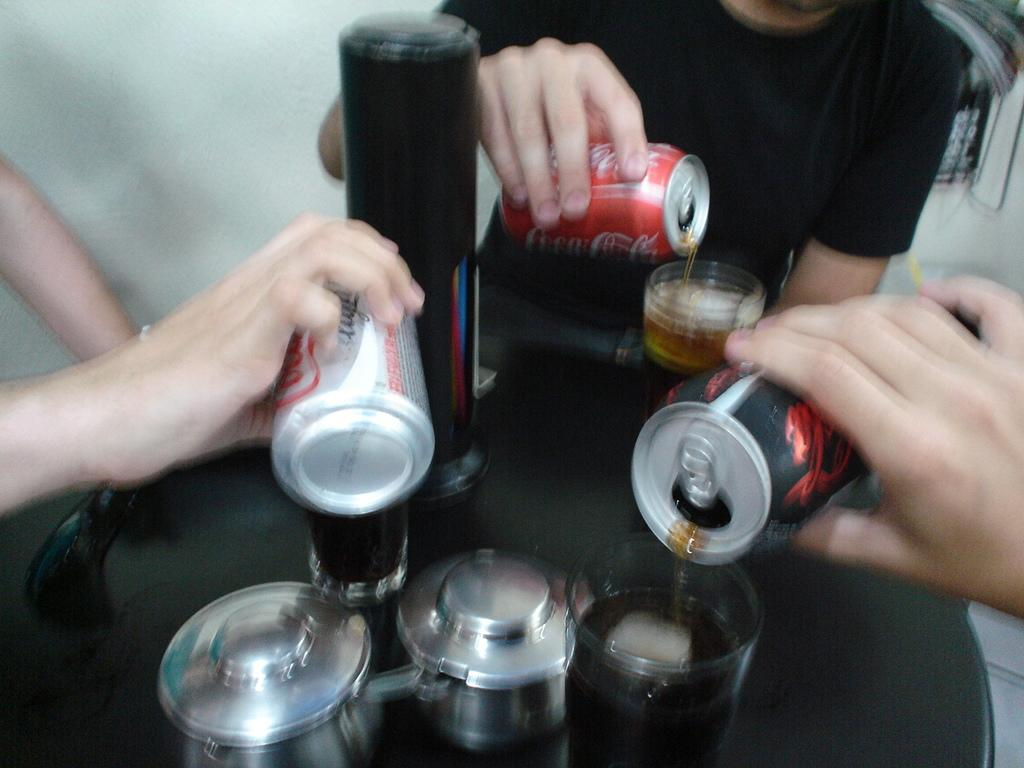What type of furniture is present in the image? There is a table in the image. What items can be seen on the table? There are beverage cans and glasses on the table. Are there any people in the image? Yes, there are people around the table. What type of alarm is ringing in the image? There is no alarm present in the image. What adjustments are being made to the table in the image? There are no adjustments being made to the table in the image. 